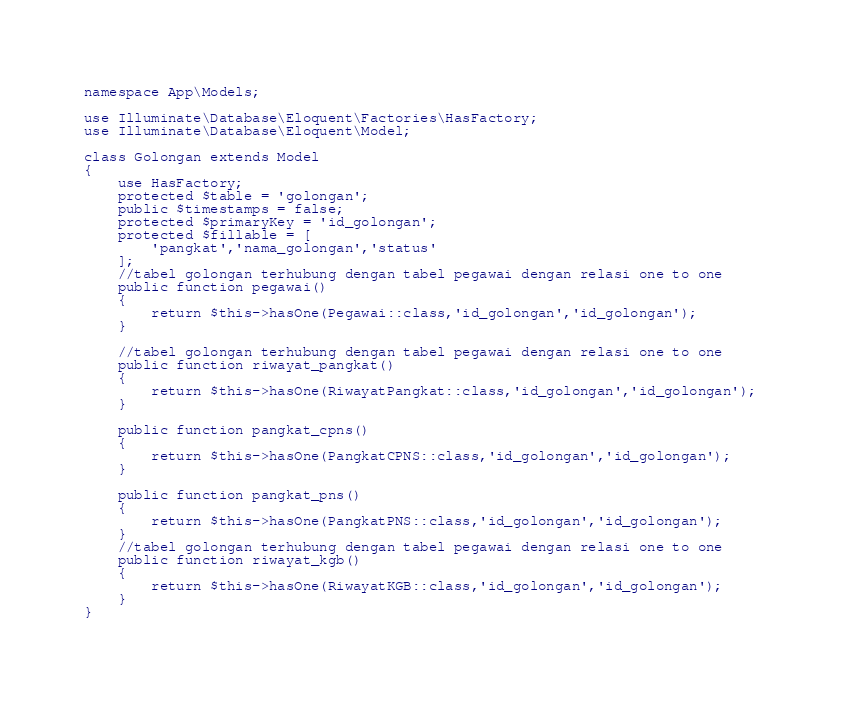<code> <loc_0><loc_0><loc_500><loc_500><_PHP_>namespace App\Models;

use Illuminate\Database\Eloquent\Factories\HasFactory;
use Illuminate\Database\Eloquent\Model;

class Golongan extends Model
{
    use HasFactory;
    protected $table = 'golongan';
    public $timestamps = false;
    protected $primaryKey = 'id_golongan';
    protected $fillable = [
        'pangkat','nama_golongan','status'
    ];
    //tabel golongan terhubung dengan tabel pegawai dengan relasi one to one
    public function pegawai()
    {
        return $this->hasOne(Pegawai::class,'id_golongan','id_golongan');
    }

    //tabel golongan terhubung dengan tabel pegawai dengan relasi one to one
    public function riwayat_pangkat()
    {
        return $this->hasOne(RiwayatPangkat::class,'id_golongan','id_golongan');
    }

    public function pangkat_cpns()
    {
        return $this->hasOne(PangkatCPNS::class,'id_golongan','id_golongan');
    }

    public function pangkat_pns()
    {
        return $this->hasOne(PangkatPNS::class,'id_golongan','id_golongan');
    }
    //tabel golongan terhubung dengan tabel pegawai dengan relasi one to one
    public function riwayat_kgb()
    {
        return $this->hasOne(RiwayatKGB::class,'id_golongan','id_golongan');
    }
}
</code> 